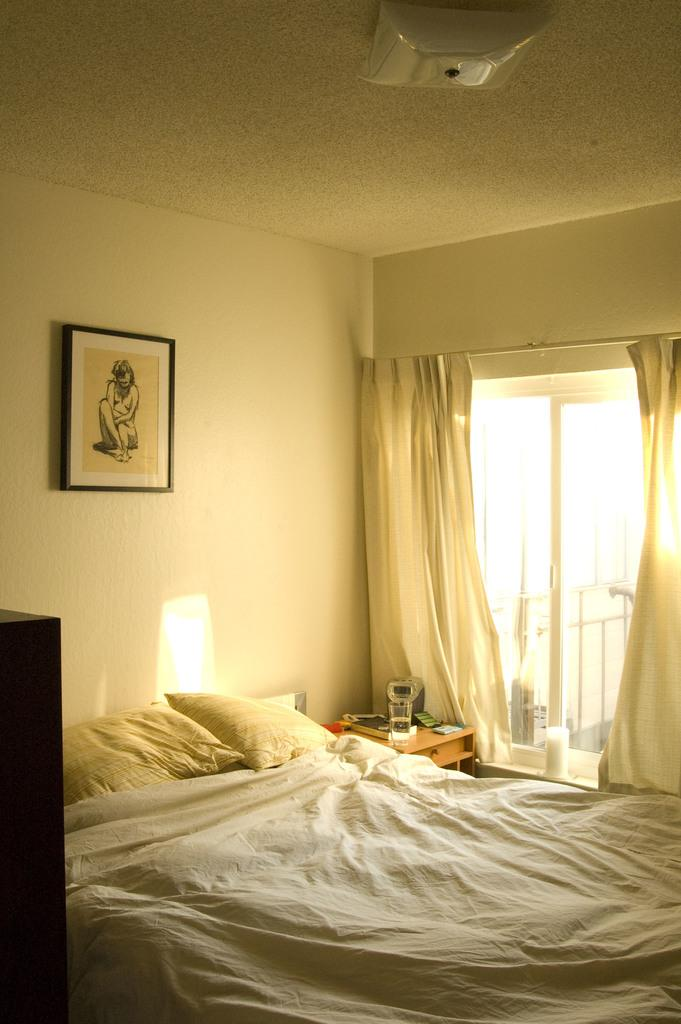What type of furniture is present in the image? There is a bed, a frame, curtains, a window, and a table in the image. How many pillows are on the bed? There are two pillows on the bed. What is the color of the bed sheet on the bed? The bed sheet on the bed is white in color. What objects can be seen on the table in the image? There are objects on the table, but their specific nature is not mentioned in the facts. Can you describe the window in the image? There is a window in the image, but its specific features are not mentioned in the facts. Can you describe the smell of the girl in the image? There is no girl present in the image, so it is not possible to describe her smell. 